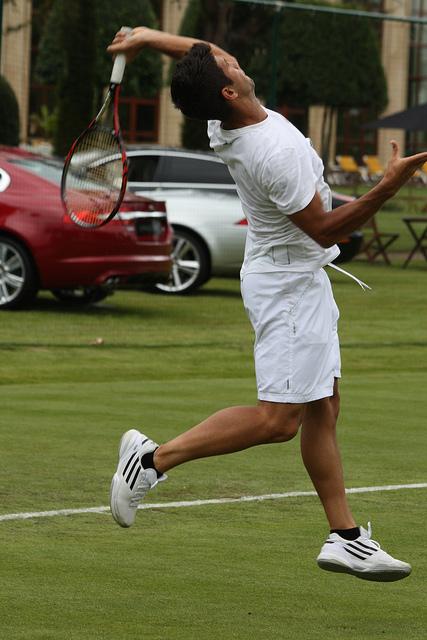What color is the men's shorts?
Concise answer only. White. What is the man doing?
Quick response, please. Tennis. What brand are the man's shoes?
Give a very brief answer. Adidas. 